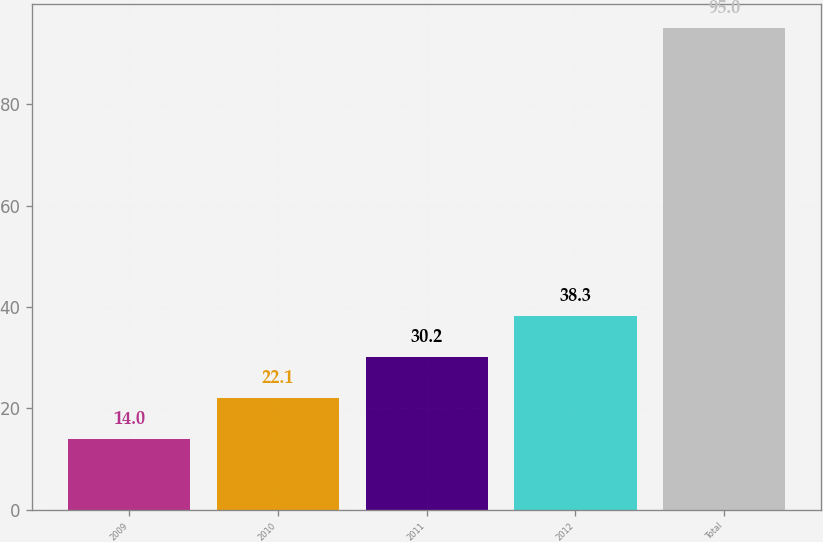Convert chart. <chart><loc_0><loc_0><loc_500><loc_500><bar_chart><fcel>2009<fcel>2010<fcel>2011<fcel>2012<fcel>Total<nl><fcel>14<fcel>22.1<fcel>30.2<fcel>38.3<fcel>95<nl></chart> 